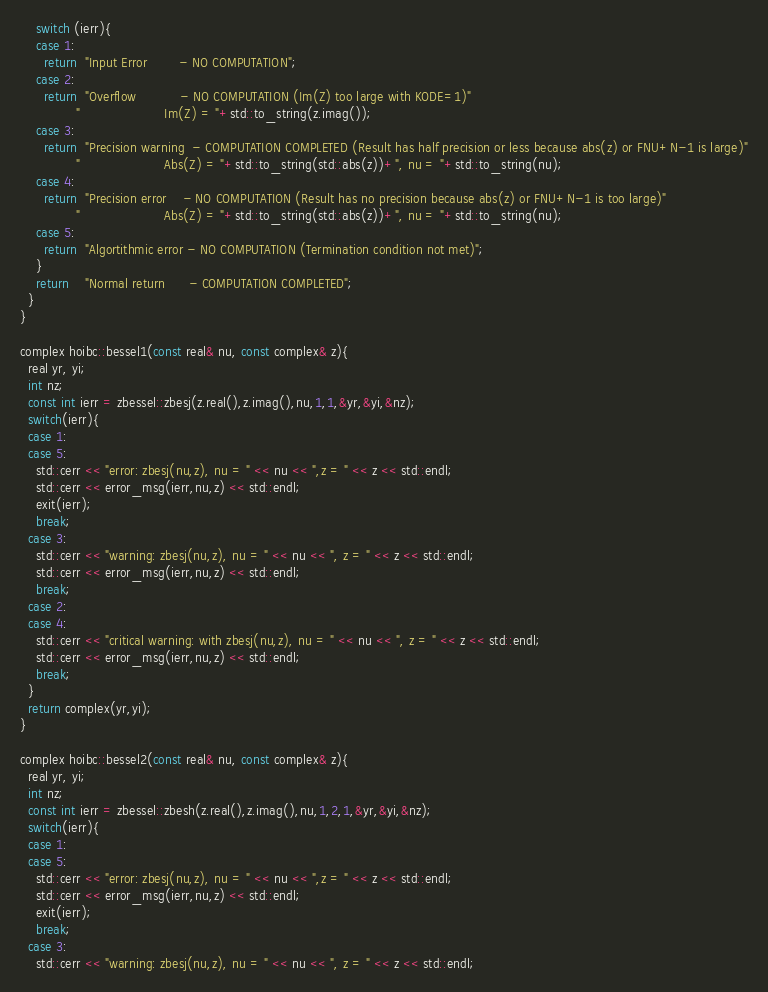Convert code to text. <code><loc_0><loc_0><loc_500><loc_500><_C++_>    switch (ierr){
    case 1:
      return  "Input Error        - NO COMPUTATION";
    case 2:
      return  "Overflow           - NO COMPUTATION (Im(Z) too large with KODE=1)"
              "                     Im(Z) = "+std::to_string(z.imag());
    case 3:
      return  "Precision warning  - COMPUTATION COMPLETED (Result has half precision or less because abs(z) or FNU+N-1 is large)"
              "                     Abs(Z) = "+std::to_string(std::abs(z))+", nu = "+std::to_string(nu);
    case 4:
      return  "Precision error    - NO COMPUTATION (Result has no precision because abs(z) or FNU+N-1 is too large)"
              "                     Abs(Z) = "+std::to_string(std::abs(z))+", nu = "+std::to_string(nu);
    case 5:
      return  "Algortithmic error - NO COMPUTATION (Termination condition not met)";
    }
    return    "Normal return      - COMPUTATION COMPLETED";
  }
}

complex hoibc::bessel1(const real& nu, const complex& z){
  real yr, yi;
  int nz;
  const int ierr = zbessel::zbesj(z.real(),z.imag(),nu,1,1,&yr,&yi,&nz);
  switch(ierr){
  case 1:
  case 5:
    std::cerr << "error: zbesj(nu,z), nu = " << nu << ",z = " << z << std::endl;
    std::cerr << error_msg(ierr,nu,z) << std::endl;
    exit(ierr);
    break;
  case 3:
    std::cerr << "warning: zbesj(nu,z), nu = " << nu << ", z = " << z << std::endl;
    std::cerr << error_msg(ierr,nu,z) << std::endl;
    break;
  case 2:
  case 4:
    std::cerr << "critical warning: with zbesj(nu,z), nu = " << nu << ", z = " << z << std::endl;
    std::cerr << error_msg(ierr,nu,z) << std::endl;
    break;
  }
  return complex(yr,yi);
}

complex hoibc::bessel2(const real& nu, const complex& z){
  real yr, yi;
  int nz;
  const int ierr = zbessel::zbesh(z.real(),z.imag(),nu,1,2,1,&yr,&yi,&nz);
  switch(ierr){
  case 1:
  case 5:
    std::cerr << "error: zbesj(nu,z), nu = " << nu << ",z = " << z << std::endl;
    std::cerr << error_msg(ierr,nu,z) << std::endl;
    exit(ierr);
    break;
  case 3:
    std::cerr << "warning: zbesj(nu,z), nu = " << nu << ", z = " << z << std::endl;</code> 